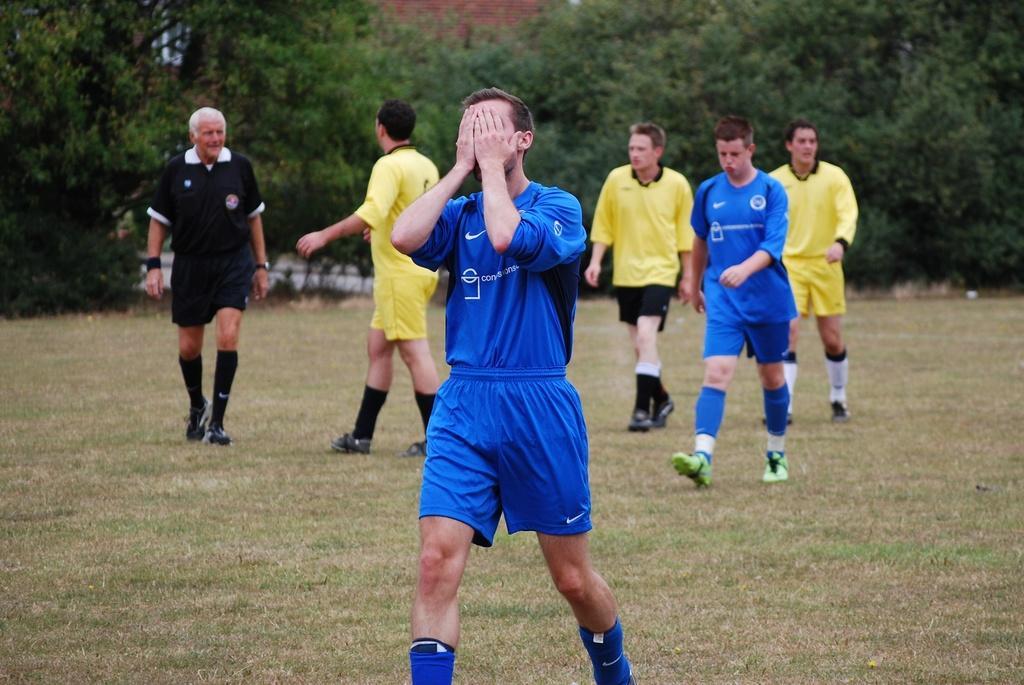Describe this image in one or two sentences. In this image, there are a few people, trees. We can see the ground with grass. In the background, we can see the wall. 